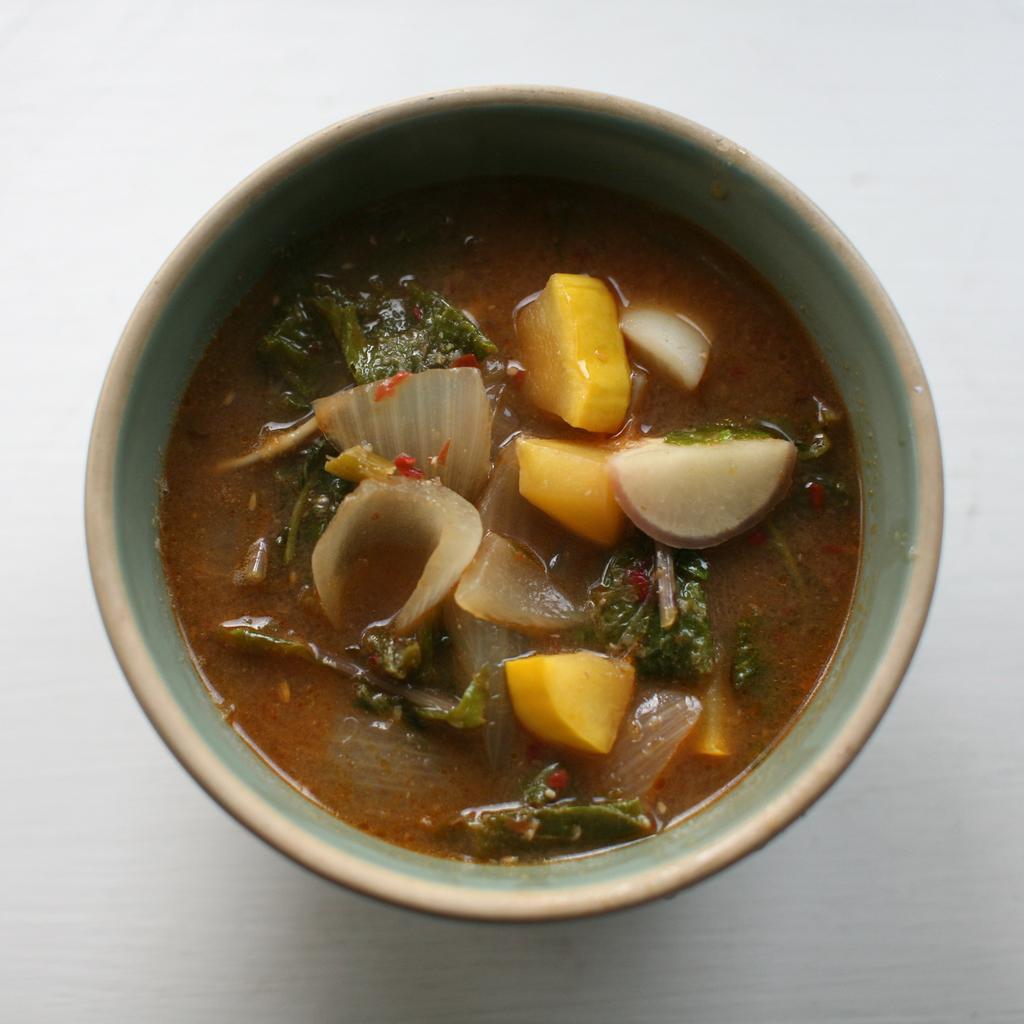Could you give a brief overview of what you see in this image? In this image, we can see a bowl with food is placed on the white surface. 